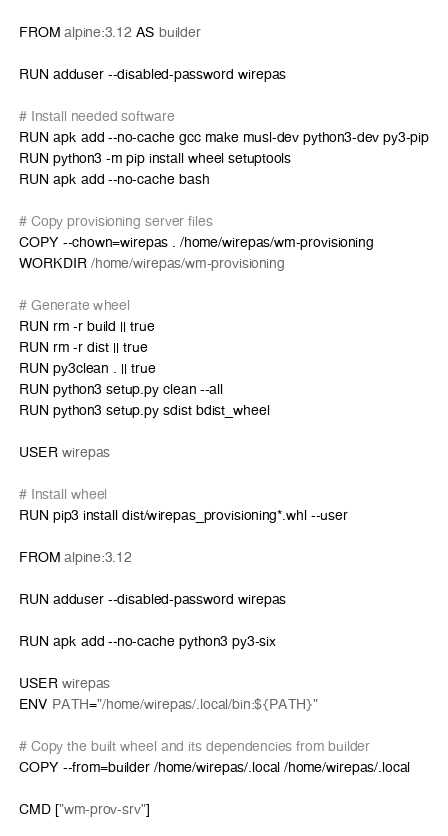<code> <loc_0><loc_0><loc_500><loc_500><_Dockerfile_>FROM alpine:3.12 AS builder

RUN adduser --disabled-password wirepas

# Install needed software
RUN apk add --no-cache gcc make musl-dev python3-dev py3-pip
RUN python3 -m pip install wheel setuptools
RUN apk add --no-cache bash

# Copy provisioning server files
COPY --chown=wirepas . /home/wirepas/wm-provisioning
WORKDIR /home/wirepas/wm-provisioning

# Generate wheel
RUN rm -r build || true
RUN rm -r dist || true
RUN py3clean . || true
RUN python3 setup.py clean --all
RUN python3 setup.py sdist bdist_wheel

USER wirepas

# Install wheel
RUN pip3 install dist/wirepas_provisioning*.whl --user

FROM alpine:3.12

RUN adduser --disabled-password wirepas

RUN apk add --no-cache python3 py3-six

USER wirepas
ENV PATH="/home/wirepas/.local/bin:${PATH}"

# Copy the built wheel and its dependencies from builder
COPY --from=builder /home/wirepas/.local /home/wirepas/.local

CMD ["wm-prov-srv"]</code> 